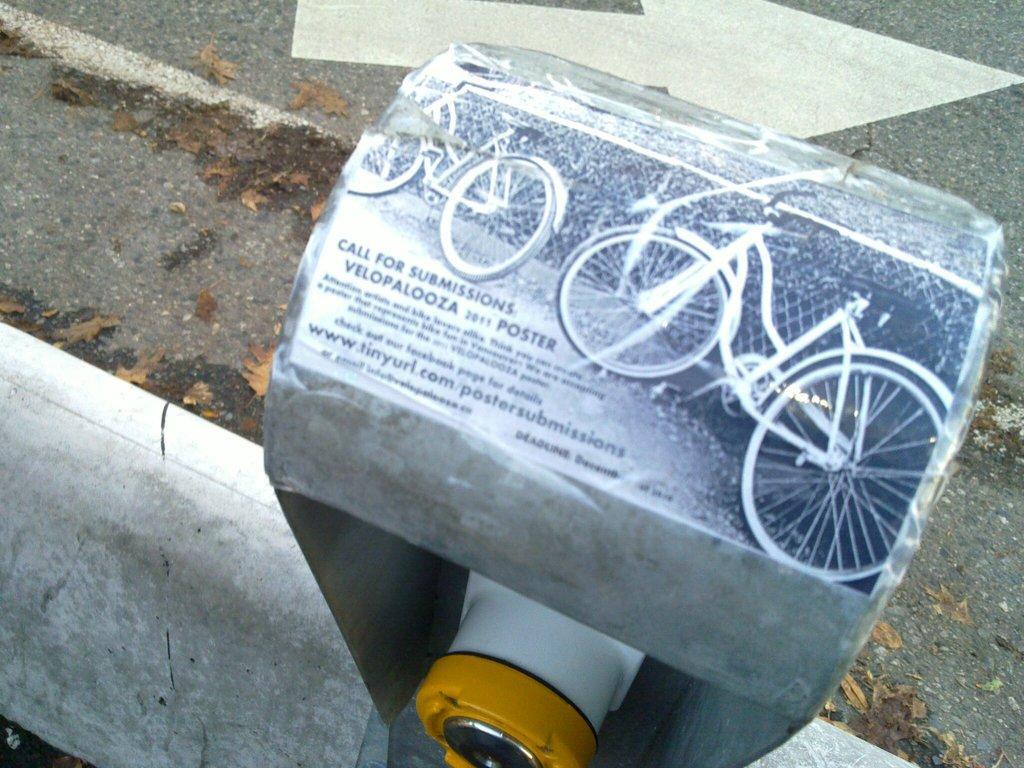Can you describe this image briefly? In this image there is a poster, machine, arrow symbol, road and dried leaves. Something is written on the poster. 